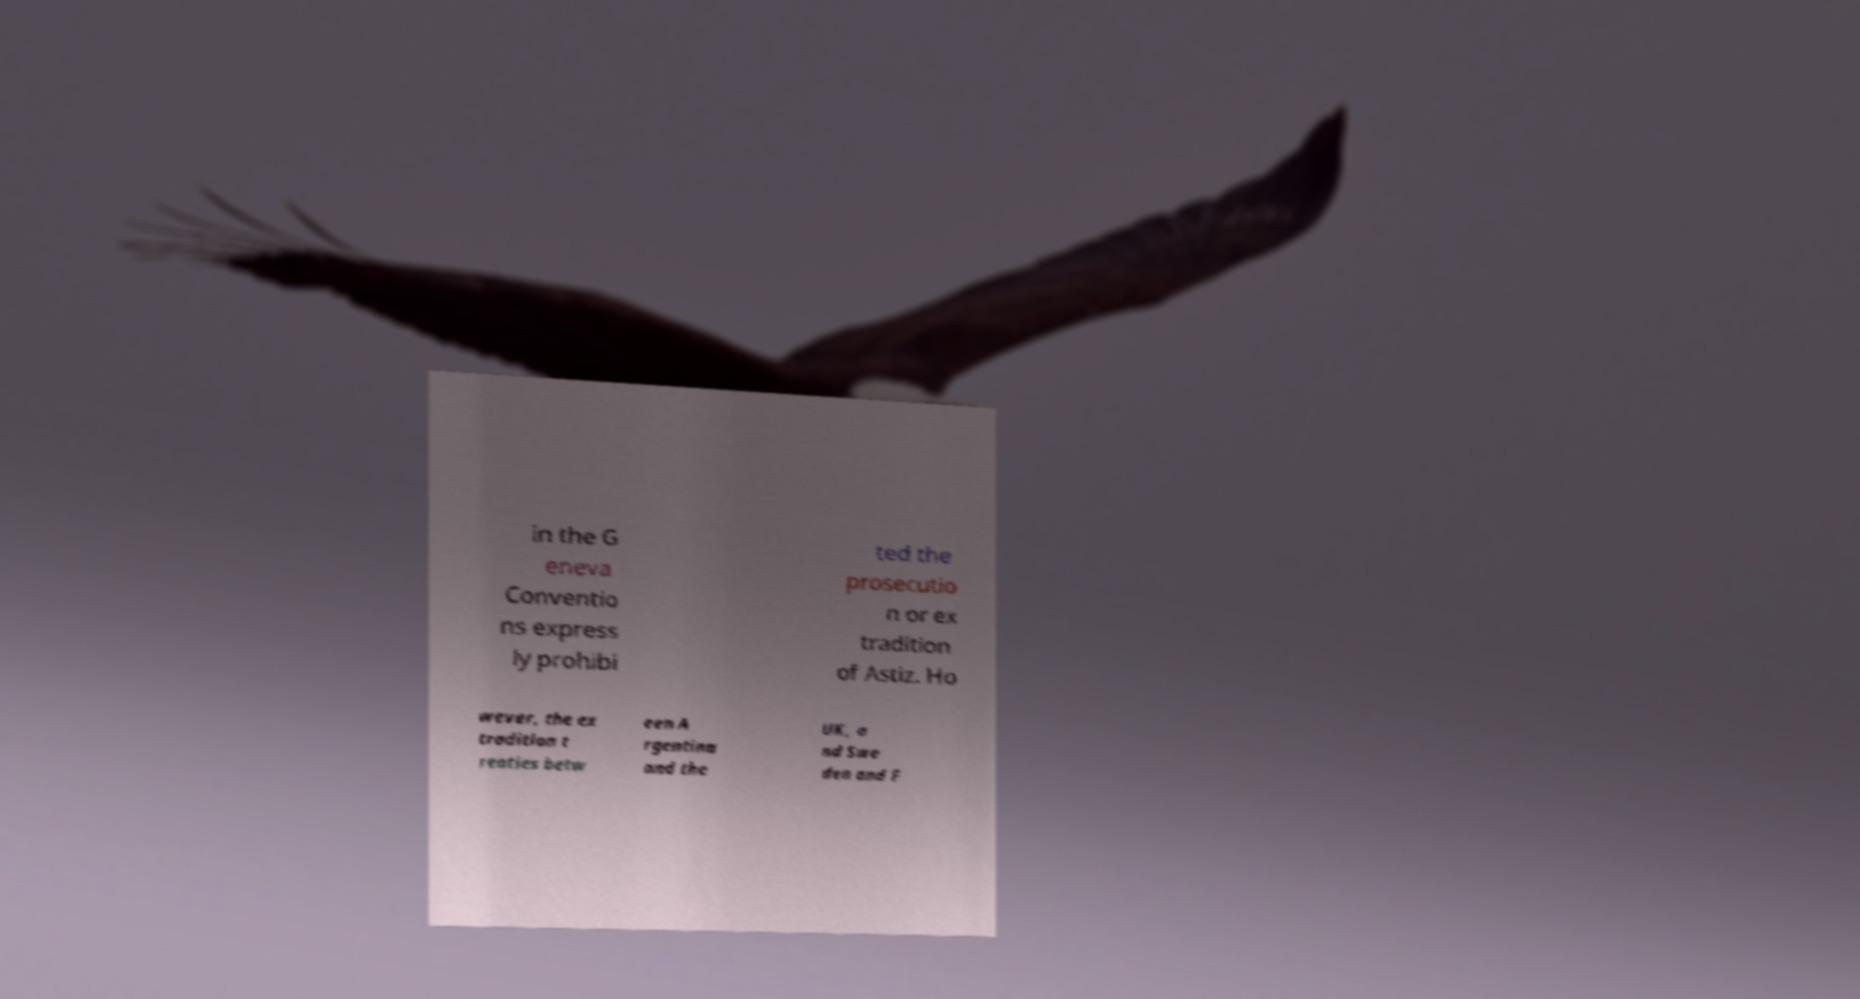I need the written content from this picture converted into text. Can you do that? in the G eneva Conventio ns express ly prohibi ted the prosecutio n or ex tradition of Astiz. Ho wever, the ex tradition t reaties betw een A rgentina and the UK, a nd Swe den and F 